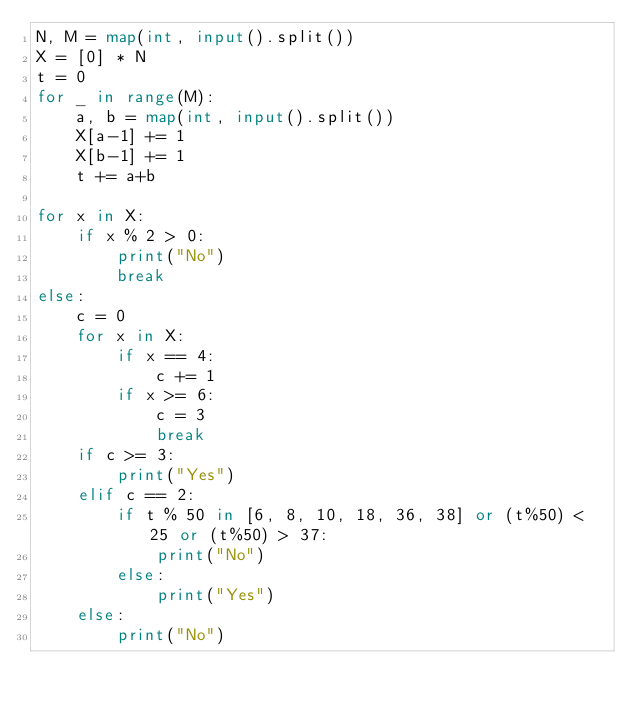Convert code to text. <code><loc_0><loc_0><loc_500><loc_500><_Python_>N, M = map(int, input().split())
X = [0] * N
t = 0
for _ in range(M):
    a, b = map(int, input().split())
    X[a-1] += 1
    X[b-1] += 1
    t += a+b
    
for x in X:
    if x % 2 > 0:
        print("No")
        break
else:
    c = 0
    for x in X:
        if x == 4:
            c += 1
        if x >= 6:
            c = 3
            break
    if c >= 3:
        print("Yes")
    elif c == 2:
        if t % 50 in [6, 8, 10, 18, 36, 38] or (t%50) < 25 or (t%50) > 37:
            print("No")
        else:
            print("Yes")
    else:
        print("No")
</code> 